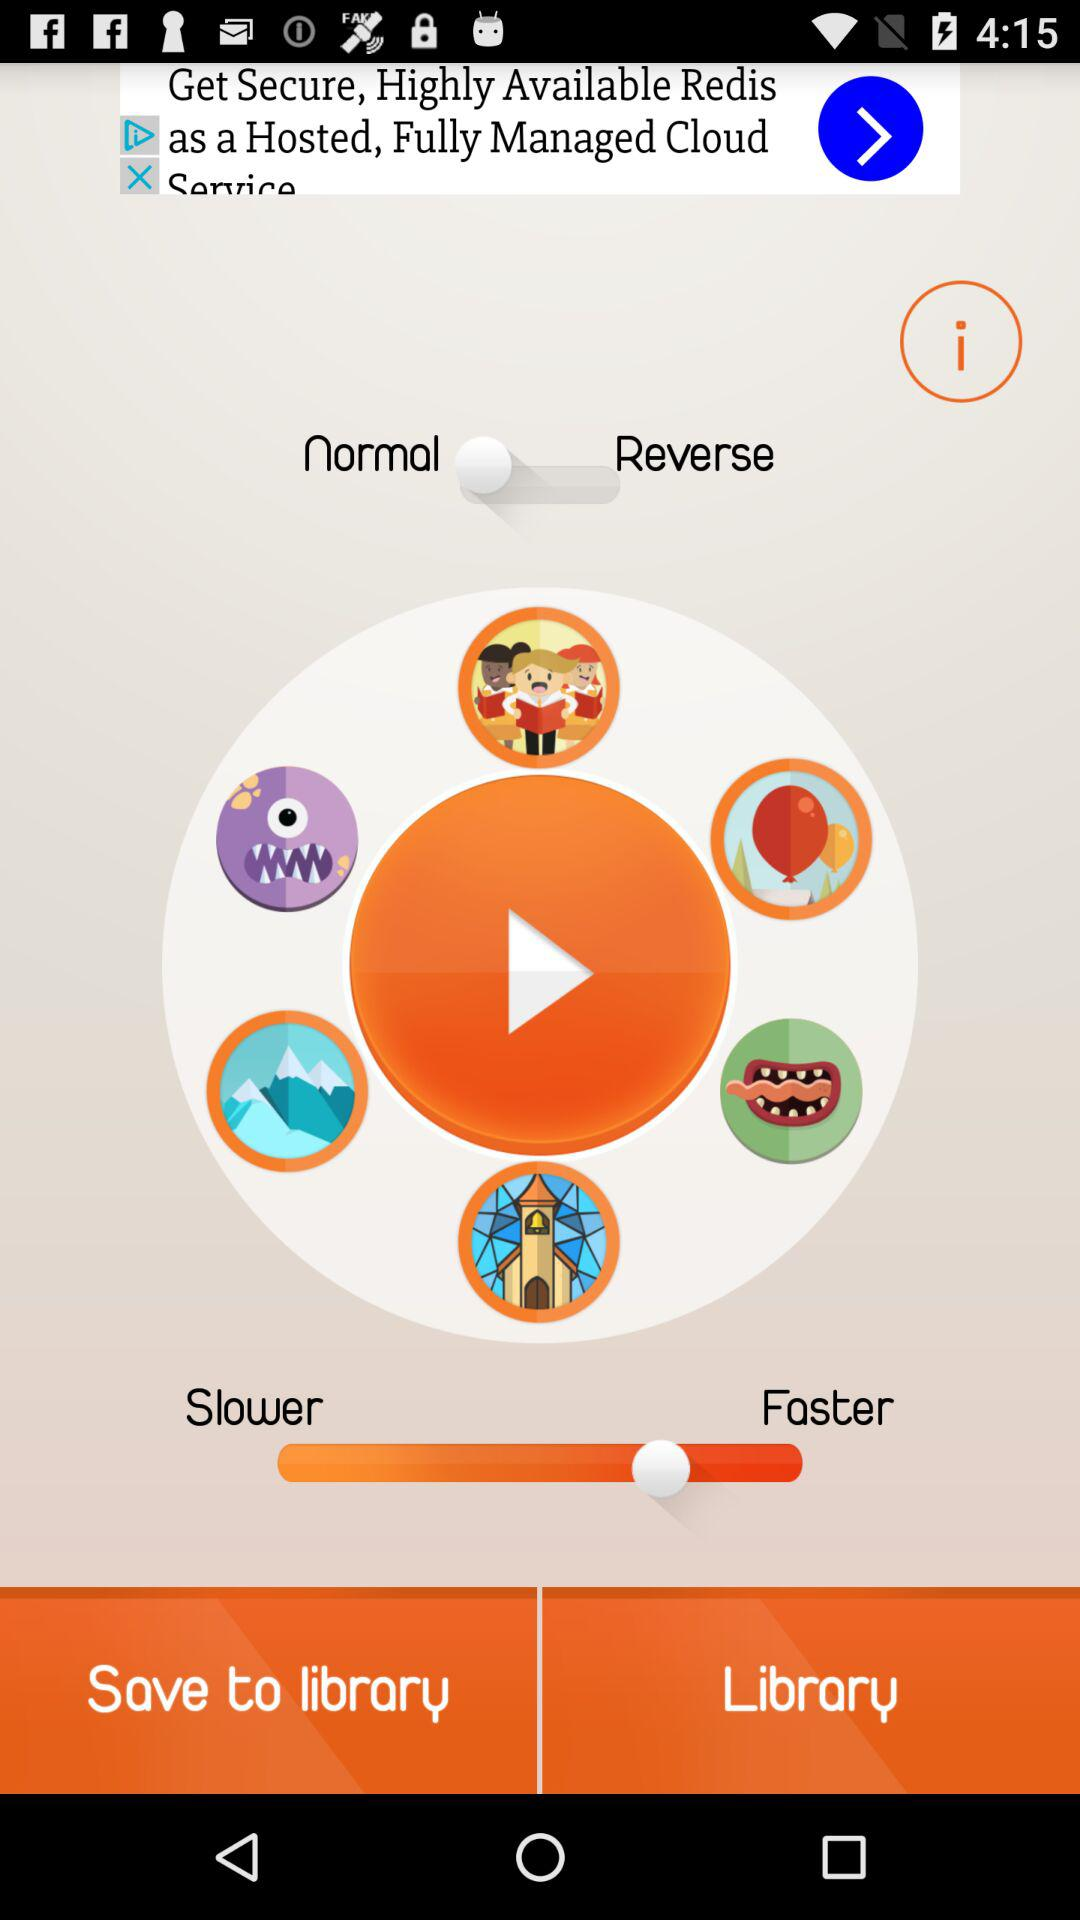Out of normal and reverse, which one is selected? Out of normal and reverse, normal is selected. 